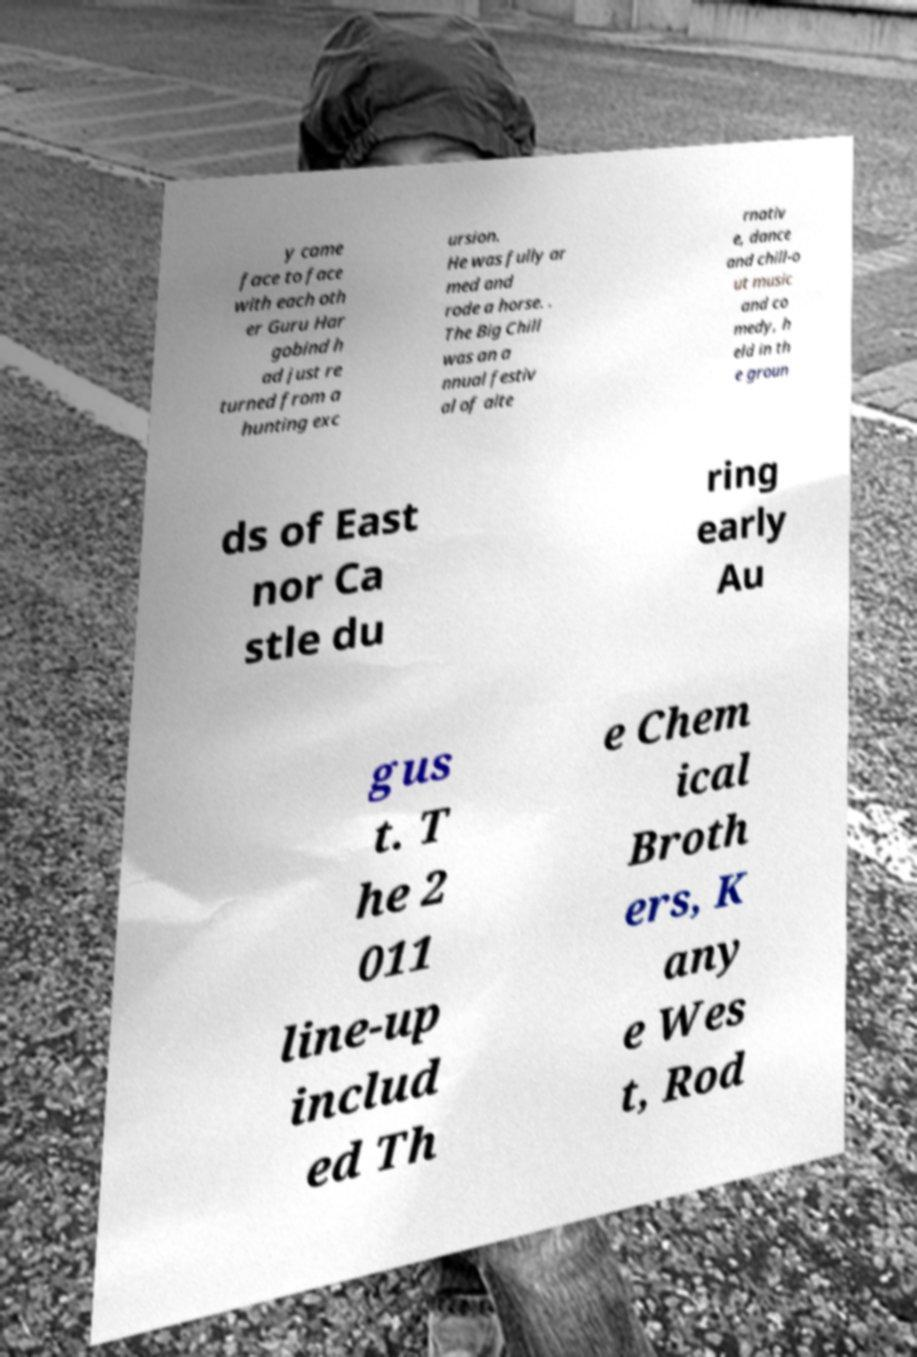Can you accurately transcribe the text from the provided image for me? y came face to face with each oth er Guru Har gobind h ad just re turned from a hunting exc ursion. He was fully ar med and rode a horse. . The Big Chill was an a nnual festiv al of alte rnativ e, dance and chill-o ut music and co medy, h eld in th e groun ds of East nor Ca stle du ring early Au gus t. T he 2 011 line-up includ ed Th e Chem ical Broth ers, K any e Wes t, Rod 